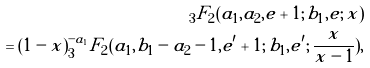<formula> <loc_0><loc_0><loc_500><loc_500>_ { 3 } F _ { 2 } ( a _ { 1 } , a _ { 2 } , e + 1 ; \, b _ { 1 } , e ; \, x ) \\ = ( 1 - x ) ^ { - a _ { 1 } } _ { 3 } F _ { 2 } ( a _ { 1 } , b _ { 1 } - a _ { 2 } - 1 , e ^ { \prime } + 1 ; \, b _ { 1 } , e ^ { \prime } ; \, \frac { x } { x - 1 } ) ,</formula> 